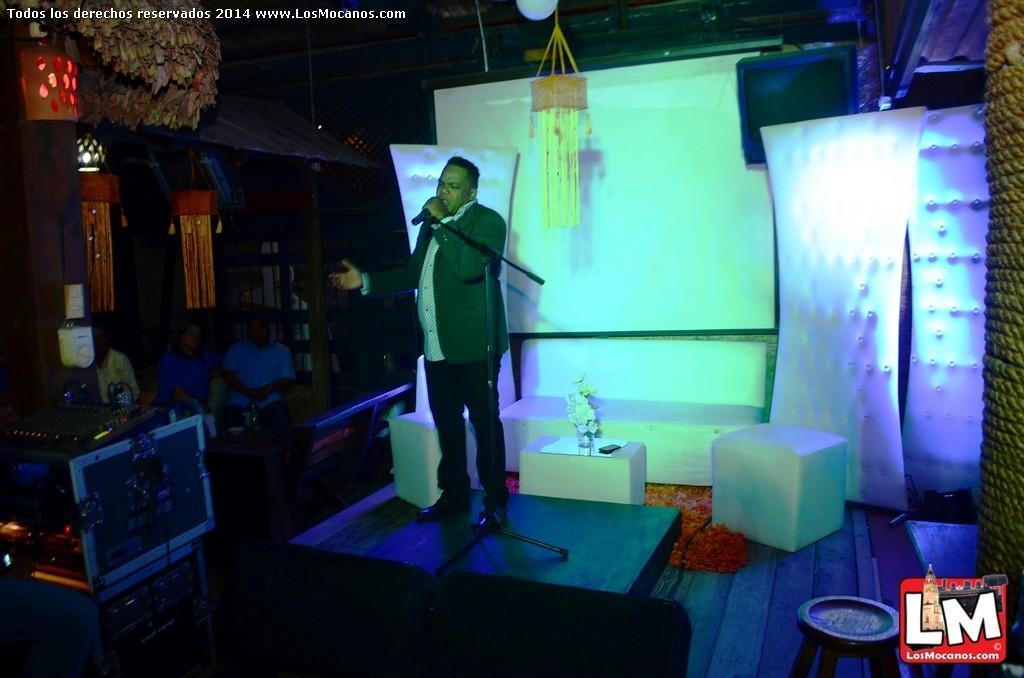Can you describe this image briefly? In the center of the picture there is a man holding a microphone and singing over a stage. In the center there are couches and flower vase. On the left there are boxes, people, chairs, decorative items. On the right there are stool and wall. 